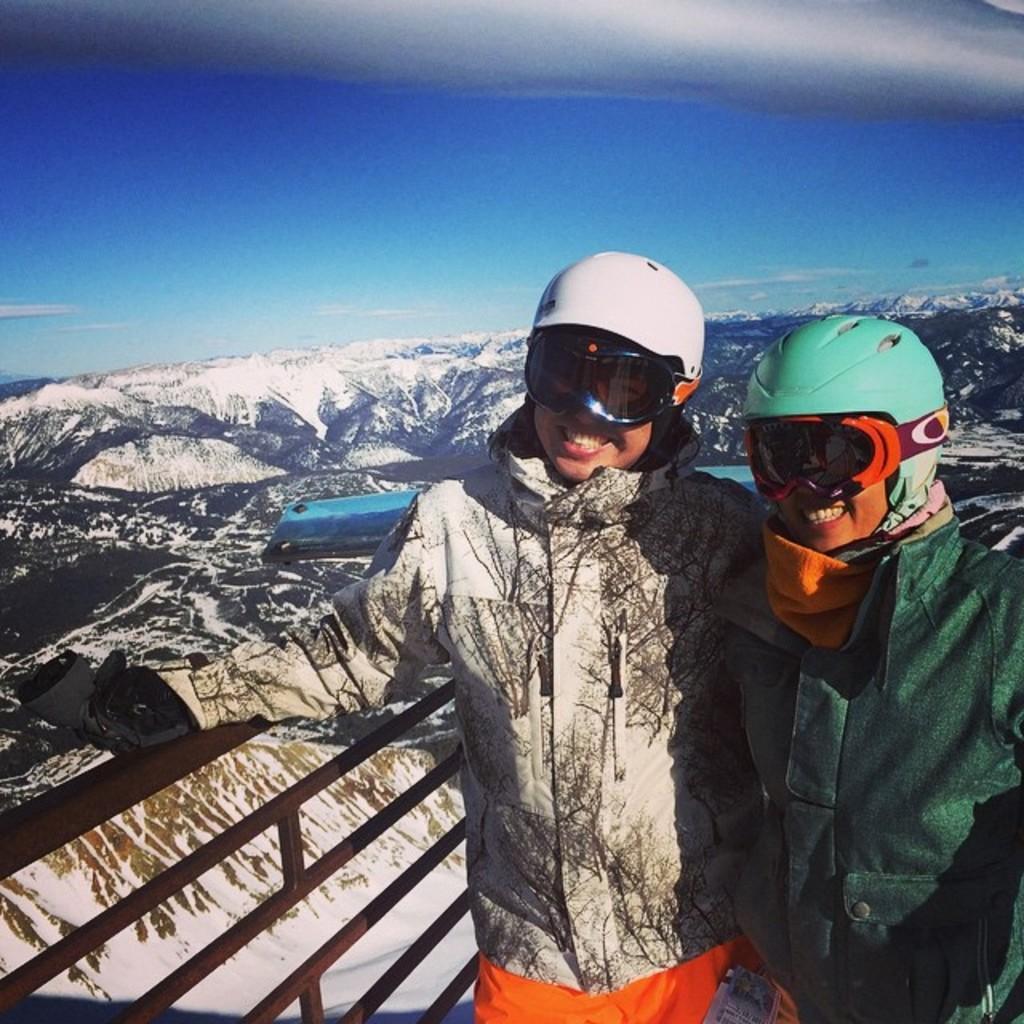Can you describe this image briefly? In this picture we can observe two women standing near this black color railing, wearing helmets and goggles. In the background there are hills which were covered with snow. We can observe sky here. 